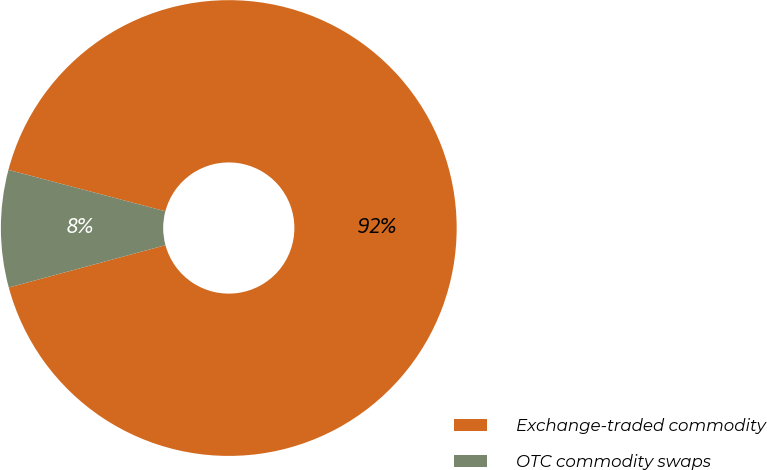<chart> <loc_0><loc_0><loc_500><loc_500><pie_chart><fcel>Exchange-traded commodity<fcel>OTC commodity swaps<nl><fcel>91.69%<fcel>8.31%<nl></chart> 